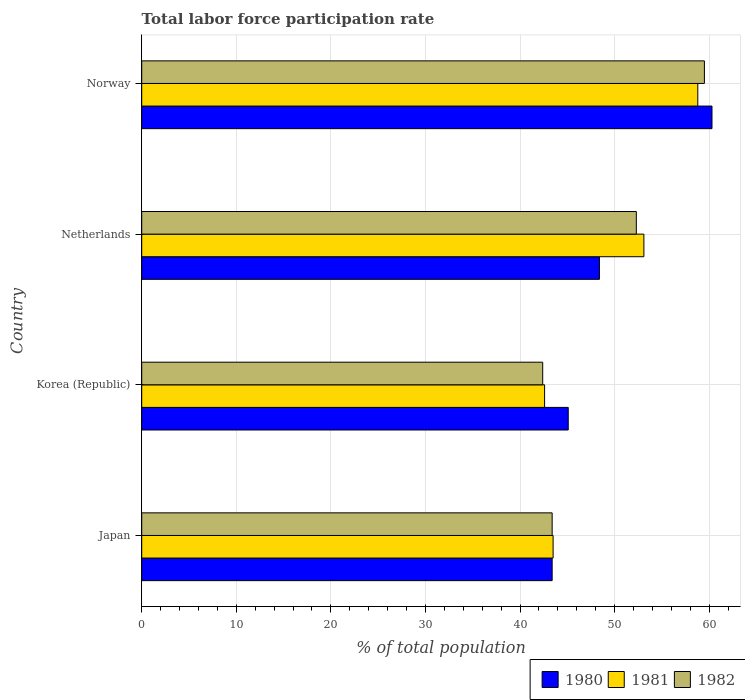How many different coloured bars are there?
Give a very brief answer. 3. Are the number of bars per tick equal to the number of legend labels?
Offer a terse response. Yes. How many bars are there on the 3rd tick from the bottom?
Keep it short and to the point. 3. What is the label of the 4th group of bars from the top?
Provide a succinct answer. Japan. In how many cases, is the number of bars for a given country not equal to the number of legend labels?
Make the answer very short. 0. What is the total labor force participation rate in 1980 in Korea (Republic)?
Provide a short and direct response. 45.1. Across all countries, what is the maximum total labor force participation rate in 1982?
Give a very brief answer. 59.5. Across all countries, what is the minimum total labor force participation rate in 1980?
Ensure brevity in your answer.  43.4. In which country was the total labor force participation rate in 1981 maximum?
Offer a very short reply. Norway. In which country was the total labor force participation rate in 1981 minimum?
Offer a terse response. Korea (Republic). What is the total total labor force participation rate in 1981 in the graph?
Offer a very short reply. 198. What is the difference between the total labor force participation rate in 1981 in Japan and that in Korea (Republic)?
Provide a short and direct response. 0.9. What is the difference between the total labor force participation rate in 1980 in Netherlands and the total labor force participation rate in 1982 in Japan?
Offer a terse response. 5. What is the average total labor force participation rate in 1981 per country?
Ensure brevity in your answer.  49.5. What is the difference between the total labor force participation rate in 1981 and total labor force participation rate in 1982 in Netherlands?
Keep it short and to the point. 0.8. What is the ratio of the total labor force participation rate in 1980 in Korea (Republic) to that in Norway?
Your answer should be compact. 0.75. Is the total labor force participation rate in 1981 in Japan less than that in Netherlands?
Offer a very short reply. Yes. Is the difference between the total labor force participation rate in 1981 in Netherlands and Norway greater than the difference between the total labor force participation rate in 1982 in Netherlands and Norway?
Give a very brief answer. Yes. What is the difference between the highest and the second highest total labor force participation rate in 1982?
Keep it short and to the point. 7.2. What is the difference between the highest and the lowest total labor force participation rate in 1982?
Offer a very short reply. 17.1. In how many countries, is the total labor force participation rate in 1980 greater than the average total labor force participation rate in 1980 taken over all countries?
Offer a very short reply. 1. Is the sum of the total labor force participation rate in 1981 in Japan and Norway greater than the maximum total labor force participation rate in 1982 across all countries?
Keep it short and to the point. Yes. What does the 2nd bar from the top in Japan represents?
Provide a short and direct response. 1981. Are all the bars in the graph horizontal?
Your response must be concise. Yes. How many countries are there in the graph?
Provide a succinct answer. 4. Are the values on the major ticks of X-axis written in scientific E-notation?
Keep it short and to the point. No. Does the graph contain any zero values?
Your response must be concise. No. What is the title of the graph?
Your answer should be compact. Total labor force participation rate. What is the label or title of the X-axis?
Offer a terse response. % of total population. What is the % of total population of 1980 in Japan?
Keep it short and to the point. 43.4. What is the % of total population in 1981 in Japan?
Ensure brevity in your answer.  43.5. What is the % of total population in 1982 in Japan?
Your answer should be compact. 43.4. What is the % of total population of 1980 in Korea (Republic)?
Offer a very short reply. 45.1. What is the % of total population of 1981 in Korea (Republic)?
Ensure brevity in your answer.  42.6. What is the % of total population of 1982 in Korea (Republic)?
Your answer should be compact. 42.4. What is the % of total population of 1980 in Netherlands?
Your answer should be compact. 48.4. What is the % of total population in 1981 in Netherlands?
Offer a terse response. 53.1. What is the % of total population of 1982 in Netherlands?
Offer a very short reply. 52.3. What is the % of total population in 1980 in Norway?
Your response must be concise. 60.3. What is the % of total population in 1981 in Norway?
Your response must be concise. 58.8. What is the % of total population of 1982 in Norway?
Ensure brevity in your answer.  59.5. Across all countries, what is the maximum % of total population of 1980?
Your response must be concise. 60.3. Across all countries, what is the maximum % of total population of 1981?
Provide a succinct answer. 58.8. Across all countries, what is the maximum % of total population in 1982?
Ensure brevity in your answer.  59.5. Across all countries, what is the minimum % of total population in 1980?
Offer a terse response. 43.4. Across all countries, what is the minimum % of total population in 1981?
Keep it short and to the point. 42.6. Across all countries, what is the minimum % of total population of 1982?
Give a very brief answer. 42.4. What is the total % of total population in 1980 in the graph?
Your response must be concise. 197.2. What is the total % of total population of 1981 in the graph?
Provide a succinct answer. 198. What is the total % of total population in 1982 in the graph?
Your answer should be very brief. 197.6. What is the difference between the % of total population of 1980 in Japan and that in Korea (Republic)?
Ensure brevity in your answer.  -1.7. What is the difference between the % of total population of 1982 in Japan and that in Netherlands?
Make the answer very short. -8.9. What is the difference between the % of total population of 1980 in Japan and that in Norway?
Provide a succinct answer. -16.9. What is the difference between the % of total population in 1981 in Japan and that in Norway?
Provide a succinct answer. -15.3. What is the difference between the % of total population of 1982 in Japan and that in Norway?
Your response must be concise. -16.1. What is the difference between the % of total population of 1980 in Korea (Republic) and that in Netherlands?
Your answer should be very brief. -3.3. What is the difference between the % of total population of 1982 in Korea (Republic) and that in Netherlands?
Provide a short and direct response. -9.9. What is the difference between the % of total population of 1980 in Korea (Republic) and that in Norway?
Your answer should be very brief. -15.2. What is the difference between the % of total population in 1981 in Korea (Republic) and that in Norway?
Make the answer very short. -16.2. What is the difference between the % of total population in 1982 in Korea (Republic) and that in Norway?
Provide a short and direct response. -17.1. What is the difference between the % of total population of 1980 in Netherlands and that in Norway?
Your answer should be compact. -11.9. What is the difference between the % of total population of 1982 in Netherlands and that in Norway?
Provide a succinct answer. -7.2. What is the difference between the % of total population in 1980 in Japan and the % of total population in 1981 in Netherlands?
Make the answer very short. -9.7. What is the difference between the % of total population in 1980 in Japan and the % of total population in 1981 in Norway?
Provide a short and direct response. -15.4. What is the difference between the % of total population in 1980 in Japan and the % of total population in 1982 in Norway?
Make the answer very short. -16.1. What is the difference between the % of total population of 1980 in Korea (Republic) and the % of total population of 1982 in Netherlands?
Give a very brief answer. -7.2. What is the difference between the % of total population of 1980 in Korea (Republic) and the % of total population of 1981 in Norway?
Provide a short and direct response. -13.7. What is the difference between the % of total population in 1980 in Korea (Republic) and the % of total population in 1982 in Norway?
Ensure brevity in your answer.  -14.4. What is the difference between the % of total population in 1981 in Korea (Republic) and the % of total population in 1982 in Norway?
Provide a short and direct response. -16.9. What is the difference between the % of total population in 1980 in Netherlands and the % of total population in 1981 in Norway?
Offer a terse response. -10.4. What is the average % of total population in 1980 per country?
Give a very brief answer. 49.3. What is the average % of total population of 1981 per country?
Provide a succinct answer. 49.5. What is the average % of total population in 1982 per country?
Offer a terse response. 49.4. What is the difference between the % of total population in 1980 and % of total population in 1981 in Japan?
Give a very brief answer. -0.1. What is the difference between the % of total population in 1980 and % of total population in 1982 in Japan?
Provide a succinct answer. 0. What is the difference between the % of total population in 1980 and % of total population in 1981 in Korea (Republic)?
Ensure brevity in your answer.  2.5. What is the difference between the % of total population in 1980 and % of total population in 1982 in Korea (Republic)?
Provide a succinct answer. 2.7. What is the difference between the % of total population of 1980 and % of total population of 1981 in Netherlands?
Your answer should be very brief. -4.7. What is the difference between the % of total population of 1981 and % of total population of 1982 in Netherlands?
Make the answer very short. 0.8. What is the difference between the % of total population in 1980 and % of total population in 1982 in Norway?
Offer a terse response. 0.8. What is the difference between the % of total population of 1981 and % of total population of 1982 in Norway?
Make the answer very short. -0.7. What is the ratio of the % of total population of 1980 in Japan to that in Korea (Republic)?
Offer a terse response. 0.96. What is the ratio of the % of total population of 1981 in Japan to that in Korea (Republic)?
Ensure brevity in your answer.  1.02. What is the ratio of the % of total population in 1982 in Japan to that in Korea (Republic)?
Give a very brief answer. 1.02. What is the ratio of the % of total population of 1980 in Japan to that in Netherlands?
Provide a succinct answer. 0.9. What is the ratio of the % of total population of 1981 in Japan to that in Netherlands?
Ensure brevity in your answer.  0.82. What is the ratio of the % of total population of 1982 in Japan to that in Netherlands?
Your answer should be compact. 0.83. What is the ratio of the % of total population of 1980 in Japan to that in Norway?
Provide a succinct answer. 0.72. What is the ratio of the % of total population in 1981 in Japan to that in Norway?
Give a very brief answer. 0.74. What is the ratio of the % of total population in 1982 in Japan to that in Norway?
Make the answer very short. 0.73. What is the ratio of the % of total population in 1980 in Korea (Republic) to that in Netherlands?
Provide a short and direct response. 0.93. What is the ratio of the % of total population in 1981 in Korea (Republic) to that in Netherlands?
Ensure brevity in your answer.  0.8. What is the ratio of the % of total population of 1982 in Korea (Republic) to that in Netherlands?
Offer a very short reply. 0.81. What is the ratio of the % of total population in 1980 in Korea (Republic) to that in Norway?
Your answer should be compact. 0.75. What is the ratio of the % of total population of 1981 in Korea (Republic) to that in Norway?
Your response must be concise. 0.72. What is the ratio of the % of total population of 1982 in Korea (Republic) to that in Norway?
Make the answer very short. 0.71. What is the ratio of the % of total population of 1980 in Netherlands to that in Norway?
Your response must be concise. 0.8. What is the ratio of the % of total population in 1981 in Netherlands to that in Norway?
Provide a succinct answer. 0.9. What is the ratio of the % of total population of 1982 in Netherlands to that in Norway?
Give a very brief answer. 0.88. What is the difference between the highest and the second highest % of total population of 1981?
Provide a succinct answer. 5.7. What is the difference between the highest and the lowest % of total population in 1981?
Provide a succinct answer. 16.2. What is the difference between the highest and the lowest % of total population in 1982?
Your response must be concise. 17.1. 